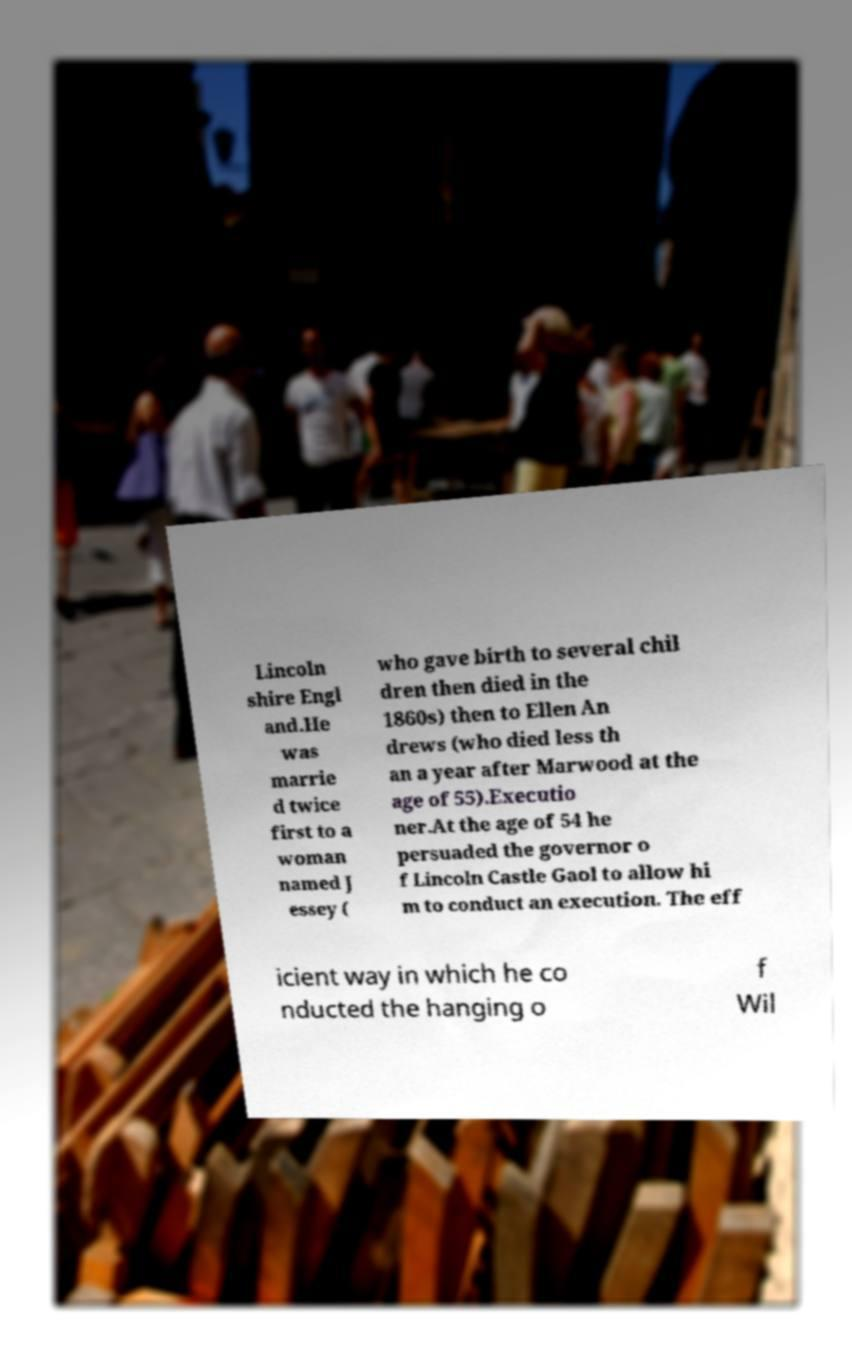For documentation purposes, I need the text within this image transcribed. Could you provide that? Lincoln shire Engl and.He was marrie d twice first to a woman named J essey ( who gave birth to several chil dren then died in the 1860s) then to Ellen An drews (who died less th an a year after Marwood at the age of 55).Executio ner.At the age of 54 he persuaded the governor o f Lincoln Castle Gaol to allow hi m to conduct an execution. The eff icient way in which he co nducted the hanging o f Wil 